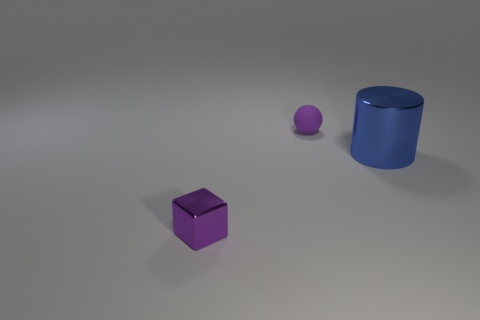Does the metal thing that is right of the ball have the same size as the metal block?
Ensure brevity in your answer.  No. The thing that is on the right side of the tiny purple metallic cube and to the left of the large blue cylinder is what color?
Provide a succinct answer. Purple. There is a tiny thing in front of the tiny purple matte thing; how many metallic cubes are in front of it?
Offer a terse response. 0. Is the shape of the small purple rubber thing the same as the tiny purple metal thing?
Provide a short and direct response. No. Is there any other thing that has the same color as the small metallic thing?
Offer a terse response. Yes. There is a small matte thing; is its shape the same as the tiny purple object that is in front of the blue object?
Ensure brevity in your answer.  No. There is a metallic thing that is on the right side of the purple object behind the small thing in front of the big blue shiny cylinder; what is its color?
Your answer should be very brief. Blue. Is there any other thing that has the same material as the purple block?
Keep it short and to the point. Yes. There is a purple object that is in front of the small ball; does it have the same shape as the blue metal object?
Offer a very short reply. No. What material is the cylinder?
Offer a very short reply. Metal. 